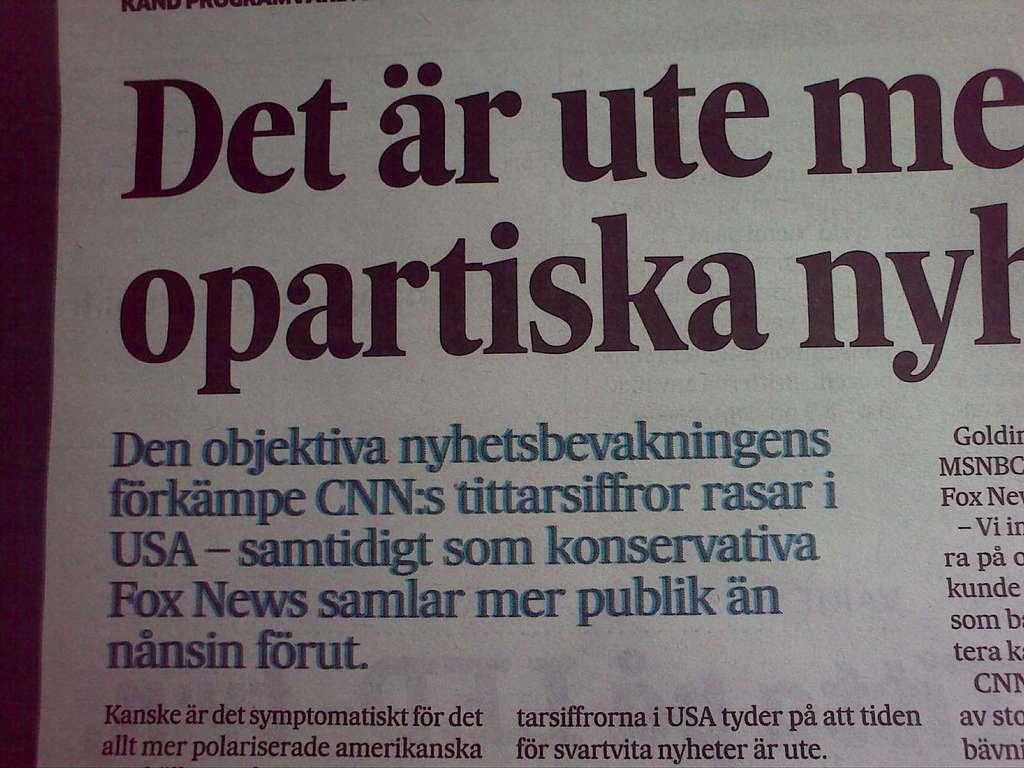<image>
Describe the image concisely. paper or magazine page with headline that starts with Det ar ute me 